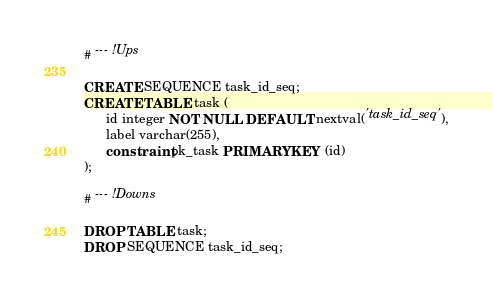<code> <loc_0><loc_0><loc_500><loc_500><_SQL_># --- !Ups

CREATE SEQUENCE task_id_seq;
CREATE TABLE task (
      id integer NOT NULL DEFAULT nextval('task_id_seq'),
      label varchar(255),
      constraint pk_task PRIMARY KEY (id)
);

# --- !Downs
 
DROP TABLE task;
DROP SEQUENCE task_id_seq;</code> 